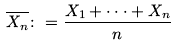Convert formula to latex. <formula><loc_0><loc_0><loc_500><loc_500>\overline { X _ { n } } \colon = \frac { X _ { 1 } + \cdot \cdot \cdot + X _ { n } } { n }</formula> 